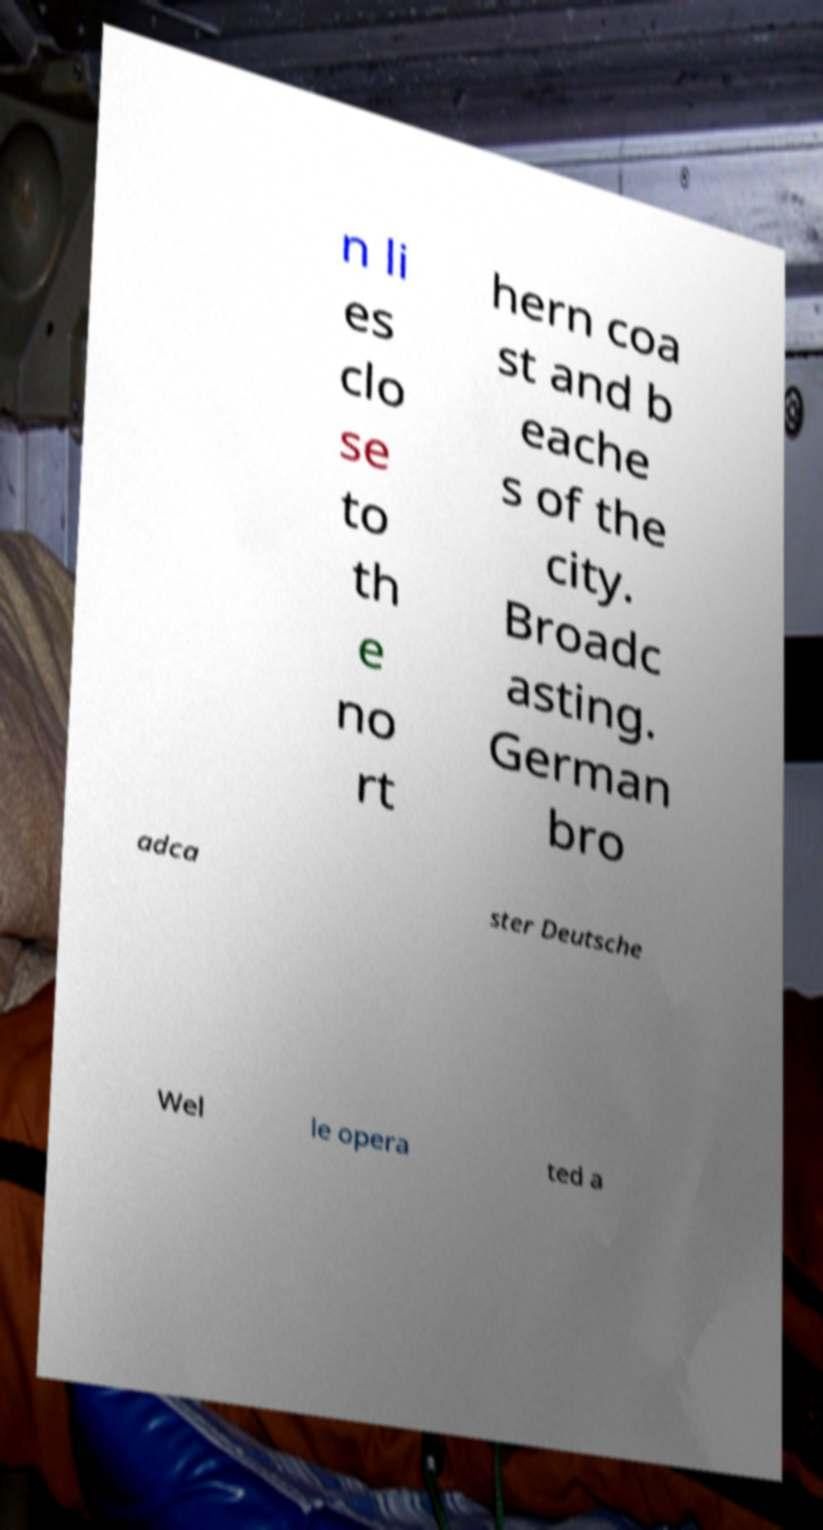What messages or text are displayed in this image? I need them in a readable, typed format. n li es clo se to th e no rt hern coa st and b eache s of the city. Broadc asting. German bro adca ster Deutsche Wel le opera ted a 